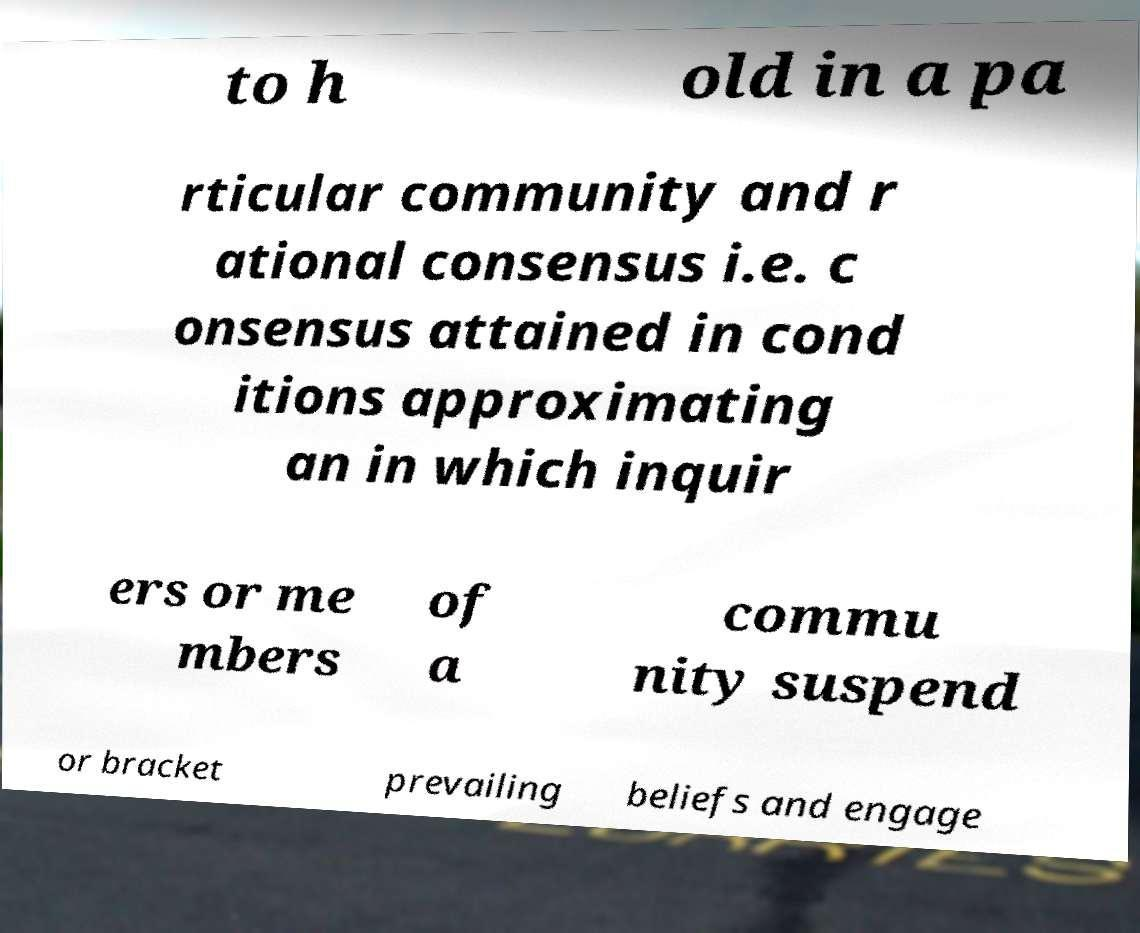Please identify and transcribe the text found in this image. to h old in a pa rticular community and r ational consensus i.e. c onsensus attained in cond itions approximating an in which inquir ers or me mbers of a commu nity suspend or bracket prevailing beliefs and engage 